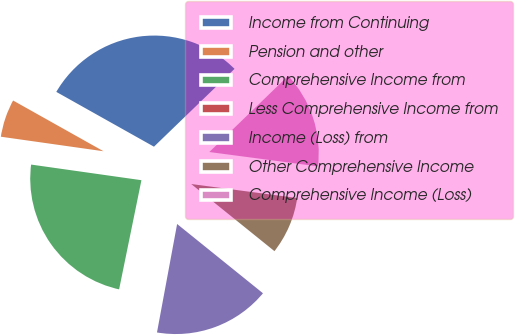Convert chart to OTSL. <chart><loc_0><loc_0><loc_500><loc_500><pie_chart><fcel>Income from Continuing<fcel>Pension and other<fcel>Comprehensive Income from<fcel>Less Comprehensive Income from<fcel>Income (Loss) from<fcel>Other Comprehensive Income<fcel>Comprehensive Income (Loss)<nl><fcel>29.64%<fcel>5.9%<fcel>24.03%<fcel>0.29%<fcel>17.12%<fcel>8.71%<fcel>14.32%<nl></chart> 